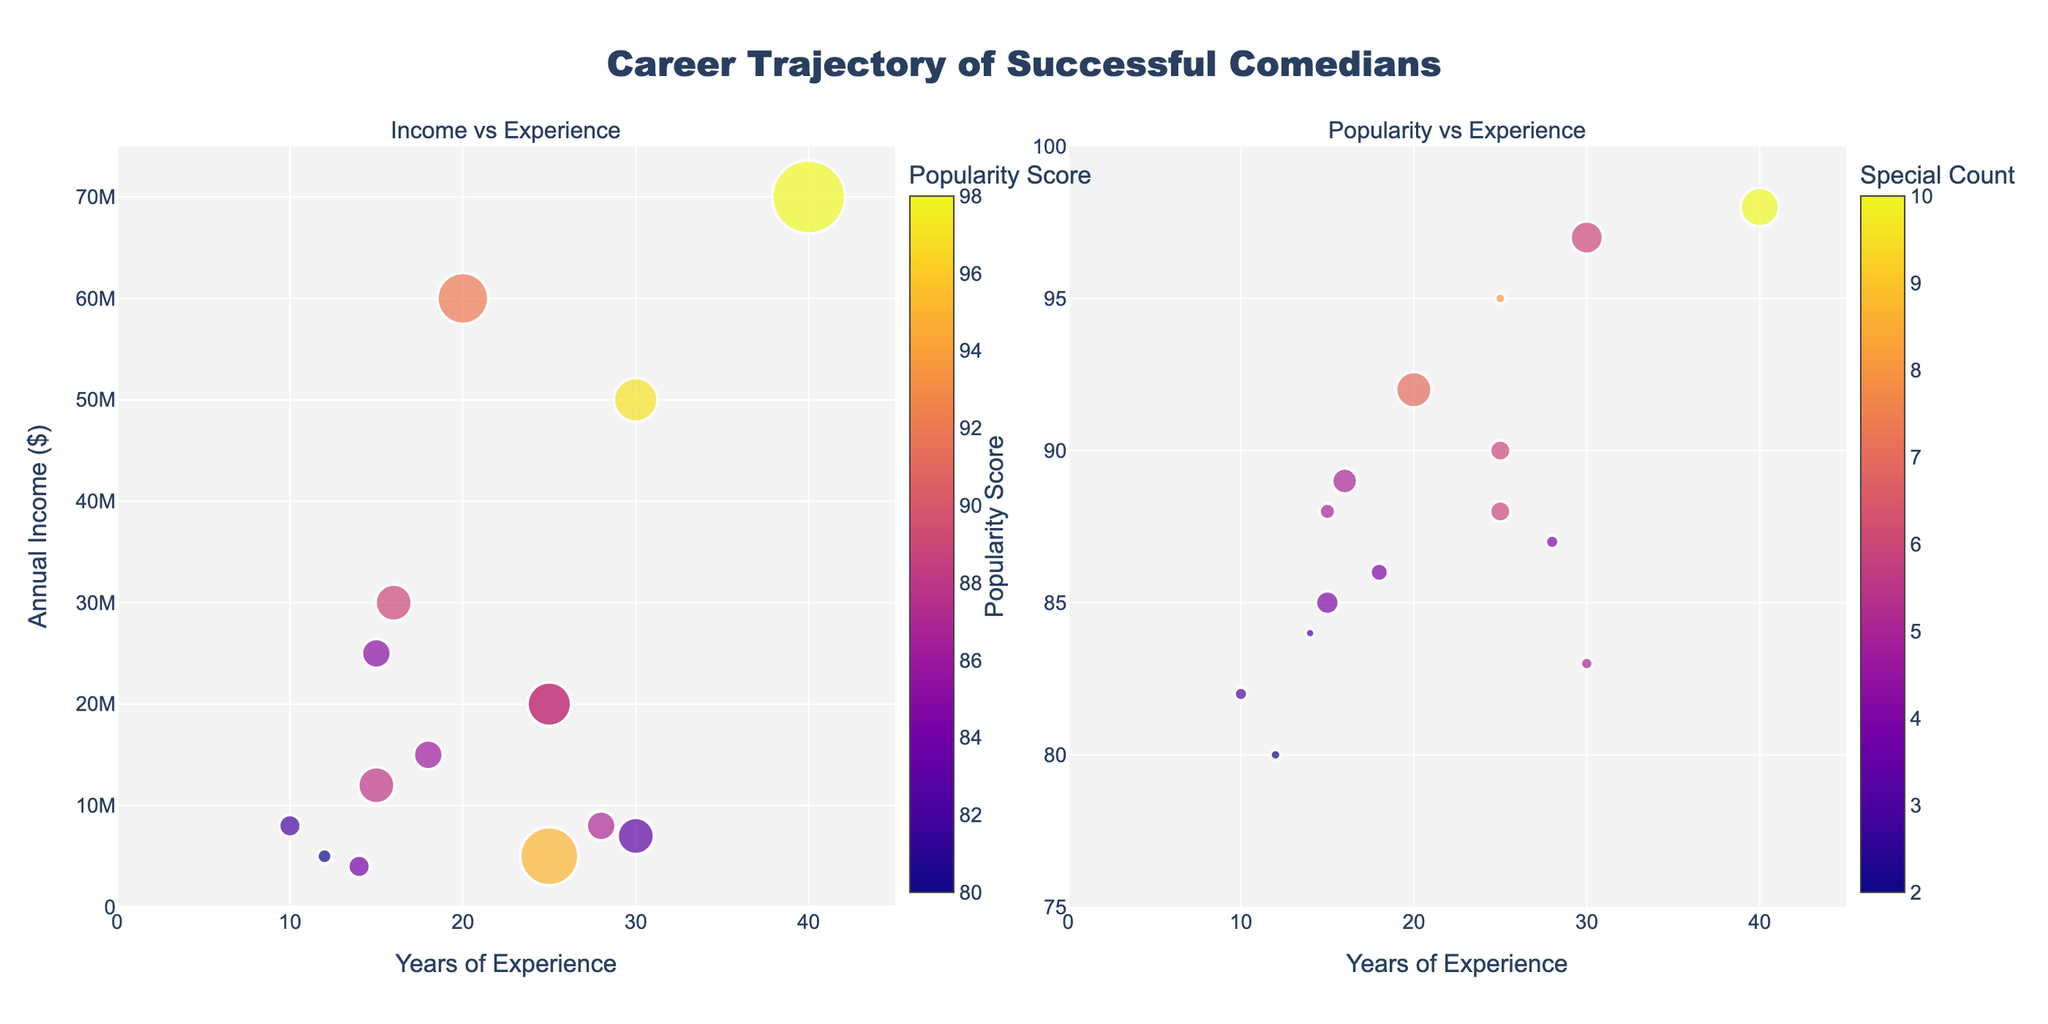how many comedians have more than 20 years of experience? By looking at the x-axis (Years of Experience), we identify comedians whose markers are to the right of 20 years. They are Steve Dylan, Jerry Seinfeld, Dave Chappelle, Kevin Hart, Bill Burr, Sarah Silverman, Jim Gaffigan
Answer: 7 which comedian has the highest annual income? The biggest marker in the "Income vs Experience" chart denotes the highest annual income. Comparing all markers, the largest one at around 40 years experience is Jerry Seinfeld with $70M
Answer: Jerry Seinfeld who has the highest popularity score with the least experience? By finding the highest point on the "Popularity vs Experience" chart on the y-axis and then identifying the marker closest to the left on the x-axis, Amy Schumer is found at 15 years with a score of 85
Answer: Amy Schumer who has the lowest popularity score and annual income? In the "Income vs Experience" chart, the smallest marker at around 12 years and an income of $4M. The corresponding dot on the "Popularity vs Experience" chart is Hannah Gadsby with a score of 80
Answer: Hannah Gadsby how many comedians have an annual income of more than $20 million? By observing the markers in the "Income vs Experience" chart, count the markers above $20M on the y-axis. These markers belong to Jerry Seinfeld, Dave Chappelle, Amy Schumer, Kevin Hart, Trevor Noah
Answer: 4 is there a correlation between the number of specials and popularity score? Since markers size denotes "Special Count" in the "Popularity vs Experience" chart, observe if larger markers align with higher popularity scores. For instance, Kevin Hart and Jerry Seinfeld have large marker sizes and high popularity scores. Generally, more specials result in higher popularity
Answer: Yes which comedian has the highest number of specials and what are their experience, income, and popularity score? By finding the largest marker in "Popularity vs Experience" chart, belonging to Jerry Seinfeld. From the dataset: 40 years of experience, income of $70M, popularity score of 98
Answer: Jerry Seinfeld; 40 years, $70M, 98 who has a similar income but higher experience compared to Sarah Silverman? Compare markers around Sarah Silverman (8M) in the "Income vs Experience" chart. Wanda Sykes has $7M and 40 years of experience, exceeding Sarah Silverman's
Answer: Wanda Sykes which comedian has the highest popularity score while having an annual income below $10 million? In the "Popularity vs Experience" chart, find the marker with the highest y-axis value with corresponding marker sizes showing income below $10M. Steve Dylan with 8 specials, a popularity score of 95 at $5M income
Answer: Steve Dylan 